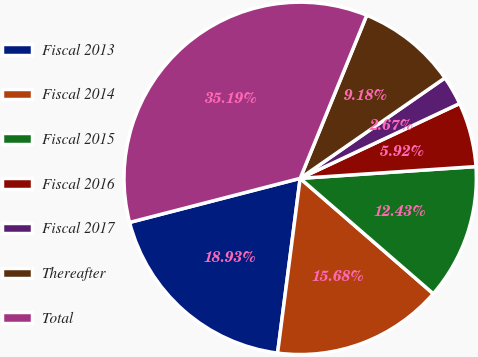<chart> <loc_0><loc_0><loc_500><loc_500><pie_chart><fcel>Fiscal 2013<fcel>Fiscal 2014<fcel>Fiscal 2015<fcel>Fiscal 2016<fcel>Fiscal 2017<fcel>Thereafter<fcel>Total<nl><fcel>18.93%<fcel>15.68%<fcel>12.43%<fcel>5.92%<fcel>2.67%<fcel>9.18%<fcel>35.19%<nl></chart> 